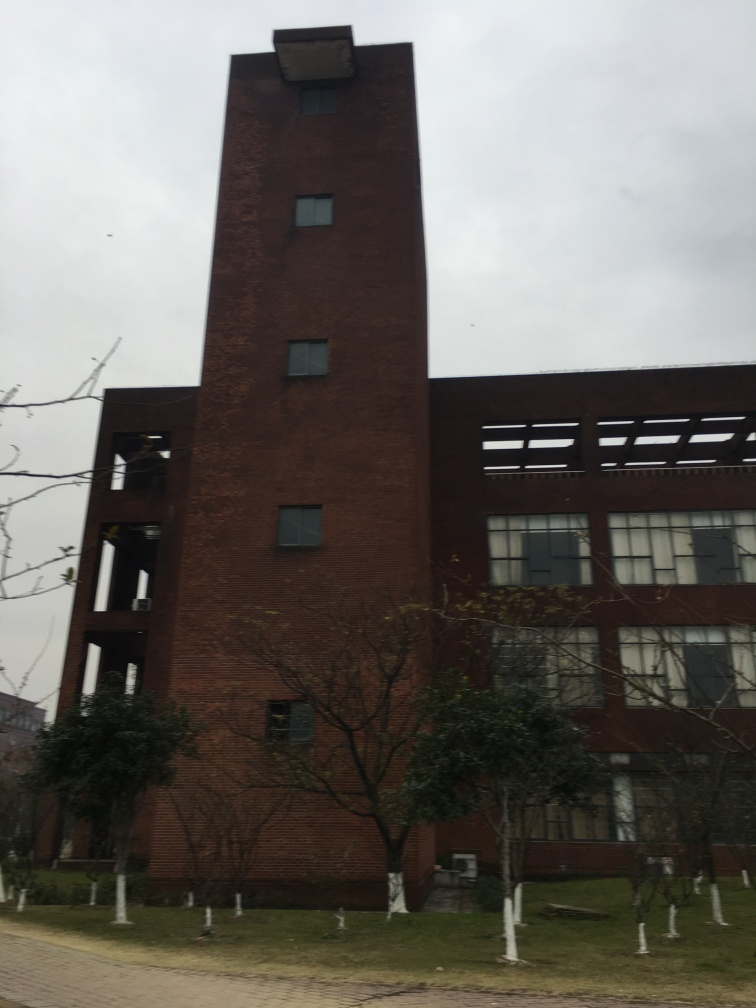Can you tell me what time of year or season it might be in this photo? Judging by the bare trees and the overcast sky, it appears to be late autumn or winter. The lack of leaves on the trees suggests that it's not the growing season, and the overall muted colors convey a sense of cold weather. 